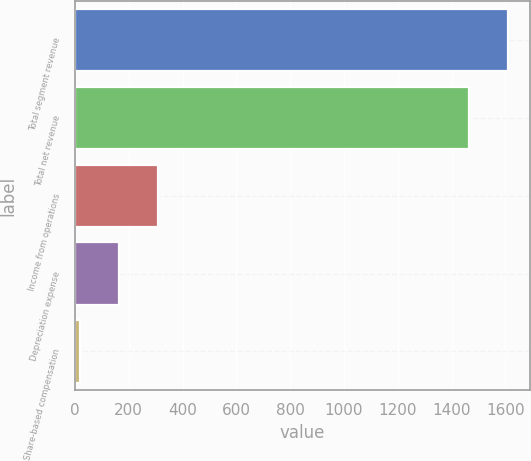<chart> <loc_0><loc_0><loc_500><loc_500><bar_chart><fcel>Total segment revenue<fcel>Total net revenue<fcel>Income from operations<fcel>Depreciation expense<fcel>Share-based compensation<nl><fcel>1610.2<fcel>1464<fcel>309.4<fcel>163.2<fcel>17<nl></chart> 